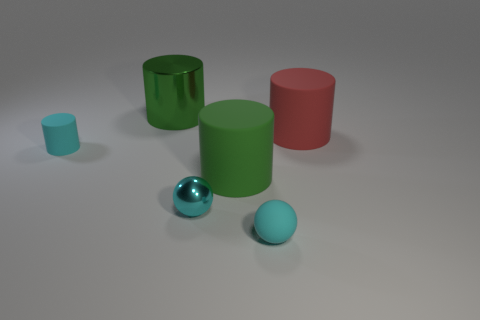Is there any indication of movement or interaction between the objects? There is no direct indication of movement or interaction between the objects, as they are stationary with no dynamic elements present in the image. 